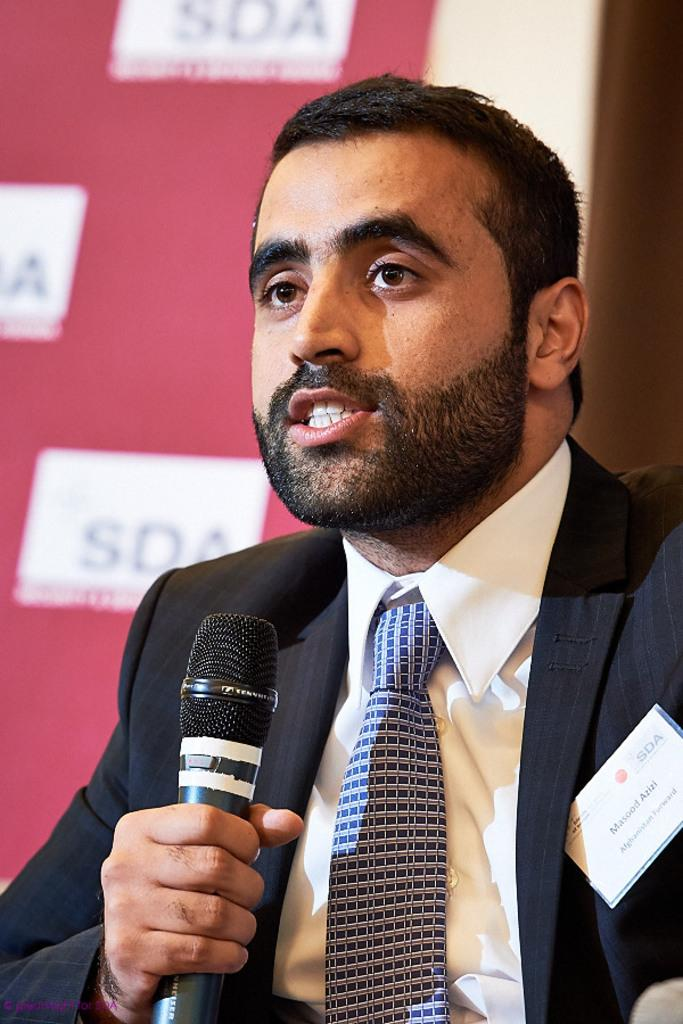Who is the main subject in the image? There is a man in the image. What is the man doing in the image? The man is talking on a microphone. What is the man wearing in the image? The man is wearing a black suit. What can be seen in the background of the image? There is a banner in the background of the image. How many cards or parcels are being delivered by the planes in the image? There are no planes or cards/parcels present in the image. 